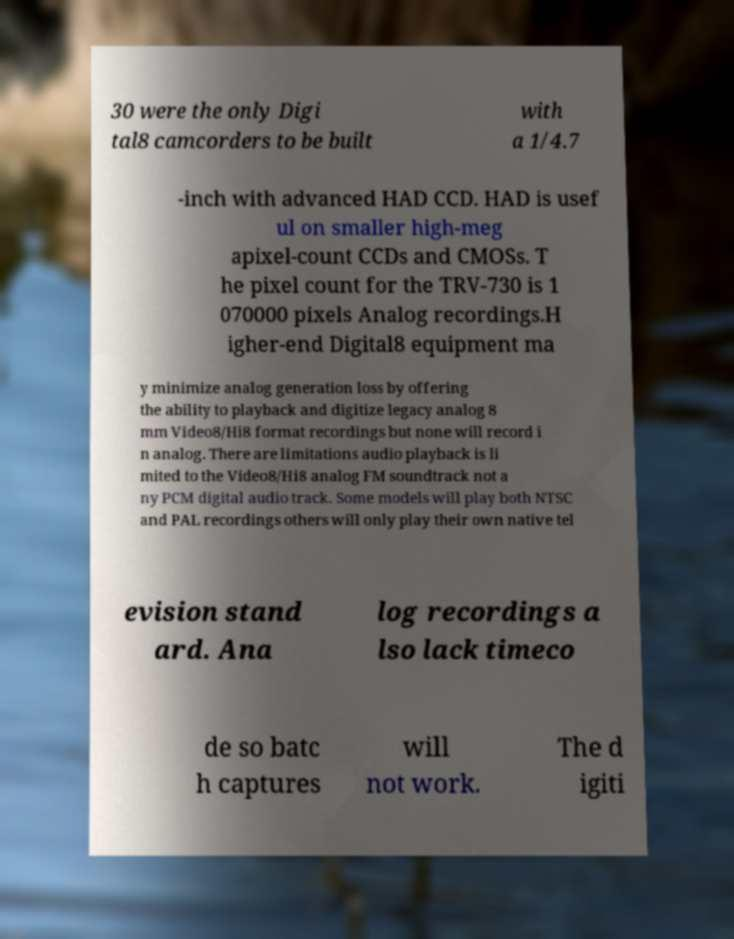There's text embedded in this image that I need extracted. Can you transcribe it verbatim? 30 were the only Digi tal8 camcorders to be built with a 1/4.7 -inch with advanced HAD CCD. HAD is usef ul on smaller high-meg apixel-count CCDs and CMOSs. T he pixel count for the TRV-730 is 1 070000 pixels Analog recordings.H igher-end Digital8 equipment ma y minimize analog generation loss by offering the ability to playback and digitize legacy analog 8 mm Video8/Hi8 format recordings but none will record i n analog. There are limitations audio playback is li mited to the Video8/Hi8 analog FM soundtrack not a ny PCM digital audio track. Some models will play both NTSC and PAL recordings others will only play their own native tel evision stand ard. Ana log recordings a lso lack timeco de so batc h captures will not work. The d igiti 